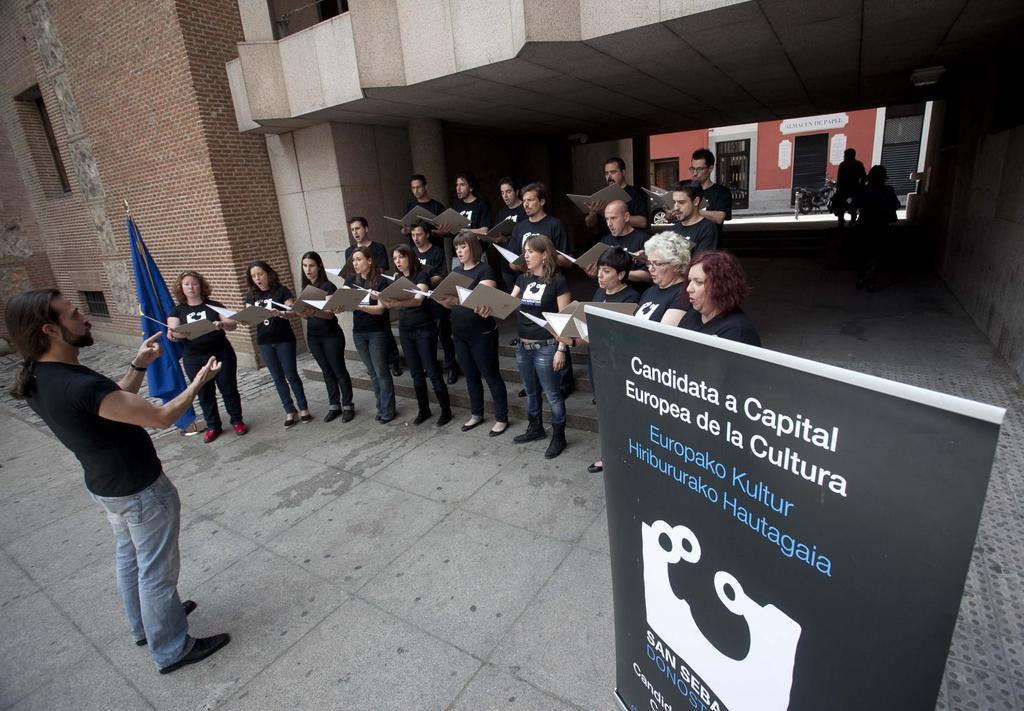Could you give a brief overview of what you see in this image? In the image we can see there are people standing and they are holding file in their hand. There is a flag and banner kept on the ground and there is a person standing. Behind there is a building and the wall of the building is made up of red bricks. There are other people standing at the back. 